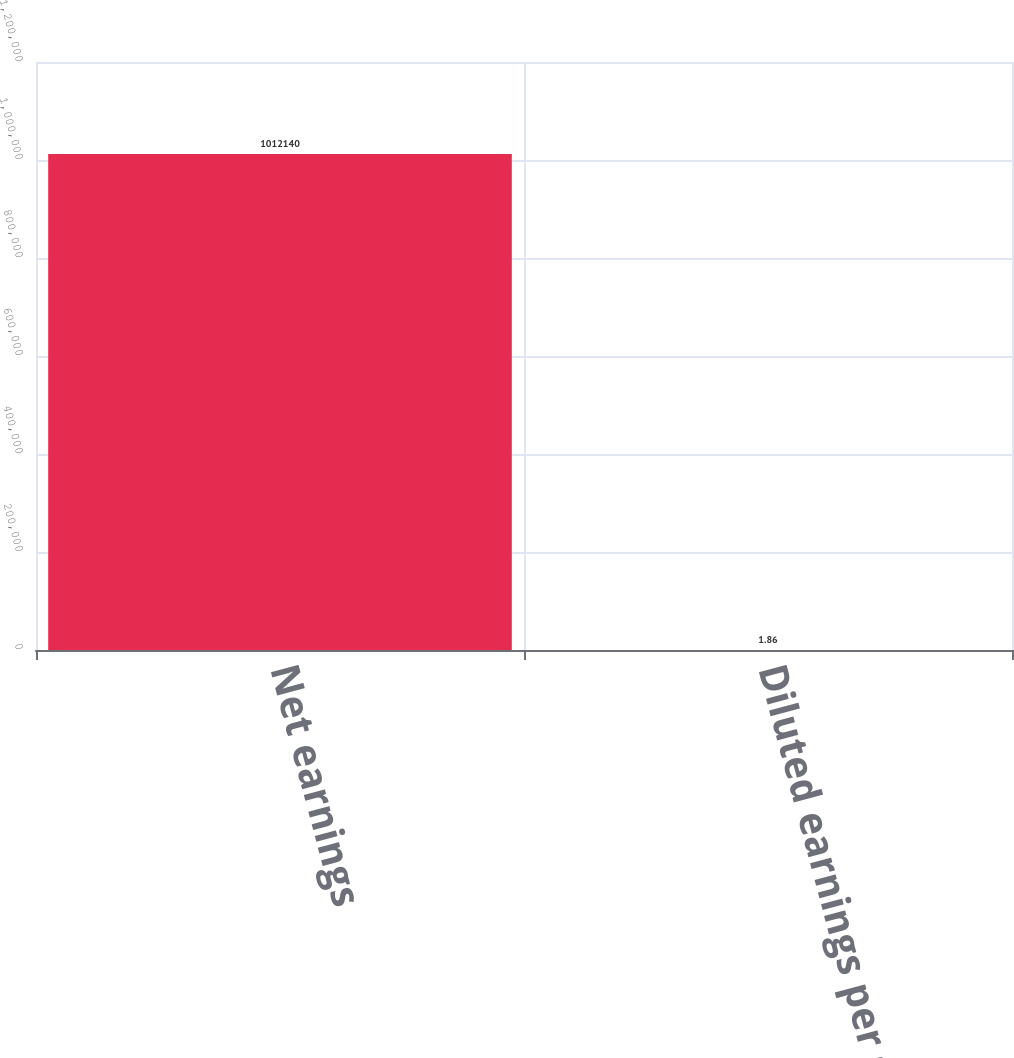Convert chart. <chart><loc_0><loc_0><loc_500><loc_500><bar_chart><fcel>Net earnings<fcel>Diluted earnings per share<nl><fcel>1.01214e+06<fcel>1.86<nl></chart> 